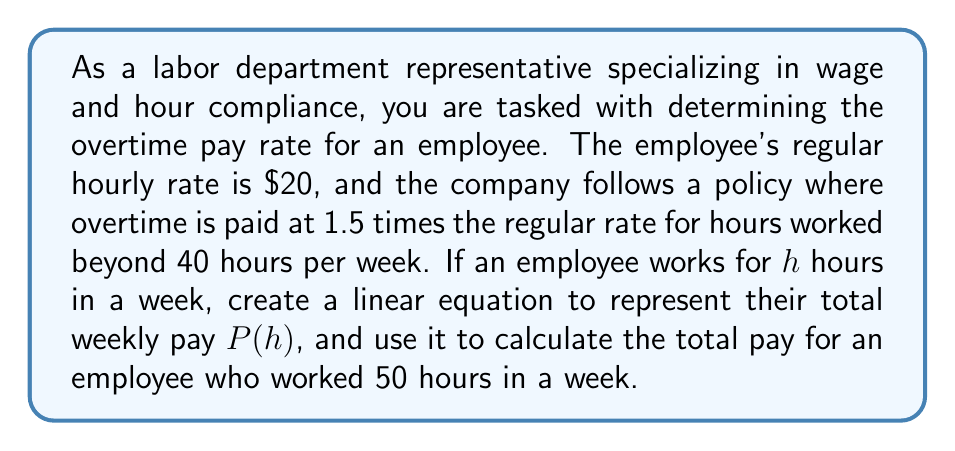Help me with this question. To solve this problem, we'll follow these steps:

1. Create a linear equation for the total weekly pay:
   We need to consider two parts: regular pay and overtime pay.
   
   Regular pay: For the first 40 hours, the employee earns their regular rate.
   $$\text{Regular pay} = 20 \times 40 = \$800$$
   
   Overtime pay: For hours beyond 40, the employee earns 1.5 times their regular rate.
   $$\text{Overtime rate} = 1.5 \times \$20 = \$30\text{ per hour}$$
   
   The number of overtime hours is $(h - 40)$ when $h > 40$.
   
   Therefore, the linear equation for total weekly pay $P(h)$ is:
   
   $$P(h) = \begin{cases}
   20h & \text{if } h \leq 40 \\
   800 + 30(h - 40) & \text{if } h > 40
   \end{cases}$$

2. Calculate the total pay for 50 hours:
   Since 50 hours is greater than 40, we use the second part of the equation:
   
   $$P(50) = 800 + 30(50 - 40)$$
   $$= 800 + 30(10)$$
   $$= 800 + 300$$
   $$= 1100$$

Therefore, the total pay for an employee who worked 50 hours in a week is $1100.
Answer: The total pay for an employee who worked 50 hours in a week is $1100. 